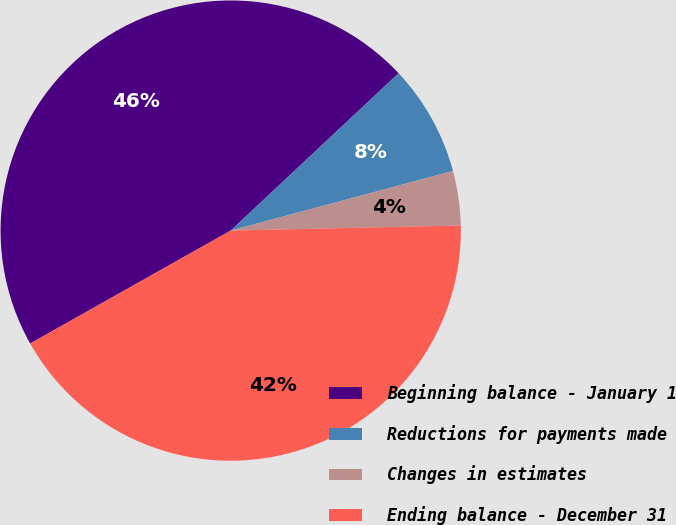Convert chart to OTSL. <chart><loc_0><loc_0><loc_500><loc_500><pie_chart><fcel>Beginning balance - January 1<fcel>Reductions for payments made<fcel>Changes in estimates<fcel>Ending balance - December 31<nl><fcel>46.18%<fcel>7.81%<fcel>3.82%<fcel>42.19%<nl></chart> 